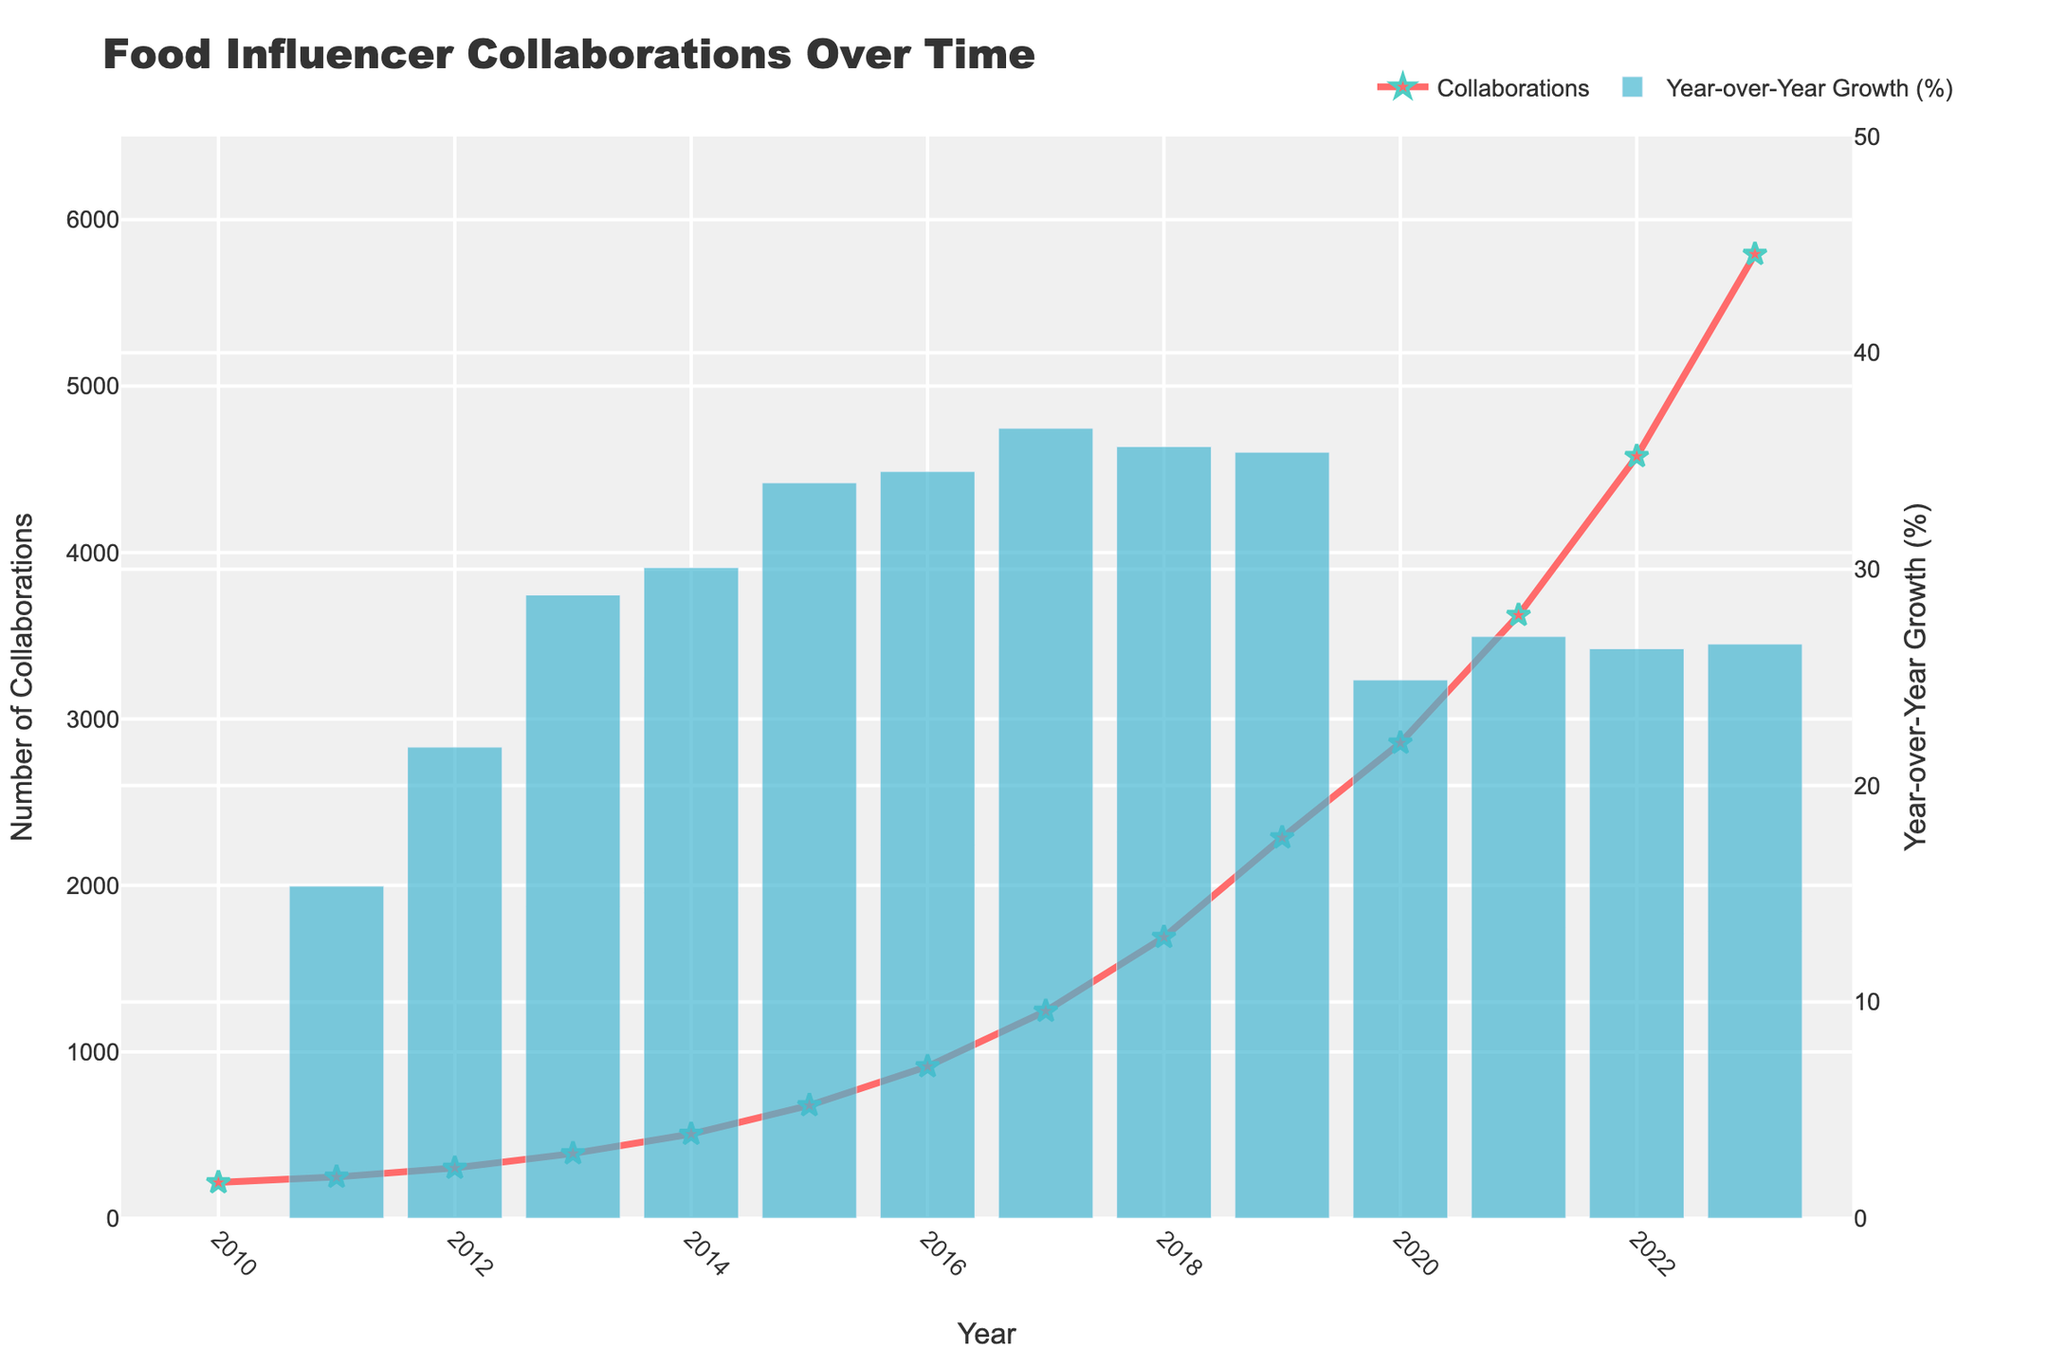How many collaborations were there in 2015? Refer to the figure and look at the "Collaborations" trend line. Observe the value for the year 2015.
Answer: 678 Which year experienced the highest number of yearly collaborations? Look at the highest point on the "Collaborations" trend line and identify its corresponding year.
Answer: 2023 What was the percentage change in the number of collaborations between 2021 and 2022? Find the heights of the bars for 2021 and 2022, which represent the percentage changes.
Answer: Year 2022 bar is height is around 26% By how much did the number of collaborations increase from 2019 to 2020? Look at the "Collaborations" trend line for the values in 2019 and 2020. Subtract the 2019 value from the 2020 value. 2856 - 2287 = 569
Answer: 569 Which two consecutive years showed the greatest year-over-year percentage increase, and what was the percentage? Identify the two bars side by side with the greatest height difference (no color coding needed here) and read their heights. Highest bars appear between 2014 and 2015.
Answer: Increase is around 34% Is the number of collaborations in 2016 greater than twice the number of collaborations in 2012? Compare the value for 2016 against twice the value of 2012. 912 (2016) and 2*302 = 604. Yes, 912 > 604.
Answer: Yes What is the overall trend observed in the collaborations from 2010 to 2023? Observe the slope and general direction of the "Collaborations" trend line. It's consistently upwards.
Answer: Upwards How does the year-over-year growth percentage (% change) behave between 2017 and 2019? Look at the height of the bars representing the percentage change for the years between 2017 and 2019 to determine their trend.
Answer: There is a decline in growth percentage 